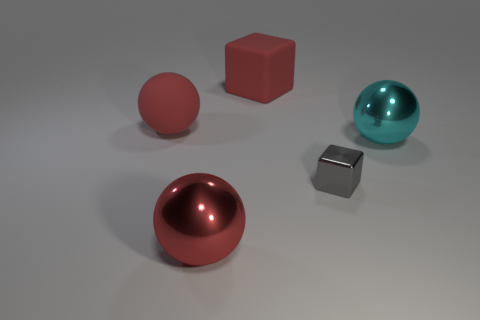What is the color of the other metallic thing that is the same size as the cyan metal object?
Your response must be concise. Red. What number of other things are there of the same color as the metal block?
Ensure brevity in your answer.  0. Is the number of large red balls in front of the big matte sphere greater than the number of red metallic spheres?
Your answer should be compact. No. Is the material of the tiny gray object the same as the cyan sphere?
Provide a short and direct response. Yes. What number of things are large matte things that are to the left of the red rubber block or large metal spheres?
Your response must be concise. 3. How many other things are there of the same size as the red cube?
Provide a short and direct response. 3. Is the number of cyan metal spheres that are on the right side of the cyan metallic ball the same as the number of rubber cubes in front of the tiny metallic thing?
Keep it short and to the point. Yes. There is another shiny object that is the same shape as the cyan shiny object; what is its color?
Offer a very short reply. Red. Is the color of the sphere in front of the cyan sphere the same as the matte sphere?
Ensure brevity in your answer.  Yes. What is the size of the red matte object that is the same shape as the tiny metallic thing?
Give a very brief answer. Large. 